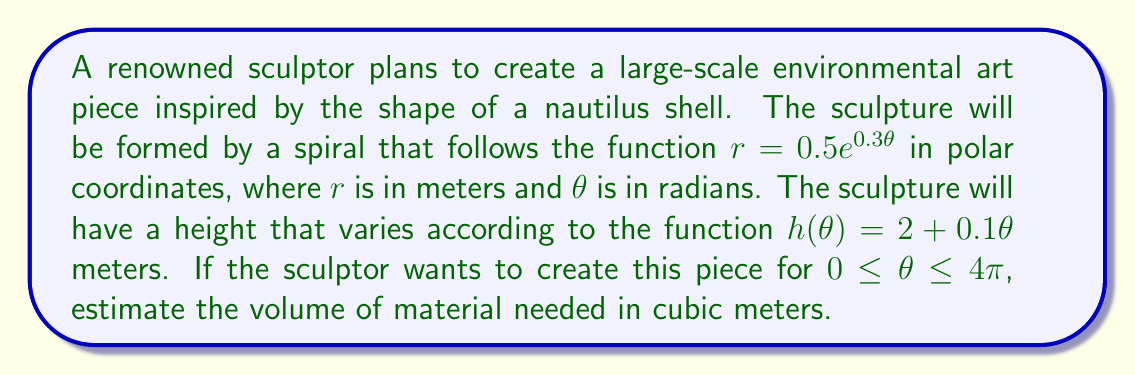Give your solution to this math problem. To estimate the volume of material needed, we need to calculate the volume of the spiral sculpture. We can do this using the volume formula for a solid with known cross-sectional area:

1) The cross-sectional area at any point is approximately a circle with radius $r$. So, the area function is:
   $A(\theta) = \pi r^2 = \pi (0.5e^{0.3\theta})^2 = 0.25\pi e^{0.6\theta}$

2) The height function is given as $h(\theta) = 2 + 0.1\theta$

3) The volume can be calculated using the integral:
   $$V = \int_0^{4\pi} A(\theta) \cdot h(\theta) \cdot d\theta$$

4) Substituting our functions:
   $$V = \int_0^{4\pi} (0.25\pi e^{0.6\theta}) \cdot (2 + 0.1\theta) \cdot d\theta$$

5) Expanding the integrand:
   $$V = 0.25\pi \int_0^{4\pi} (2e^{0.6\theta} + 0.1\theta e^{0.6\theta}) \cdot d\theta$$

6) This integral is complex to solve analytically. We can use numerical integration methods or computer algebra systems to evaluate it. Using such methods, we get:
   $$V \approx 1715.62 \text{ cubic meters}$$

7) Considering potential waste and the imprecise nature of the estimate, it would be prudent to round up to the nearest hundred cubic meters.
Answer: 1800 cubic meters 